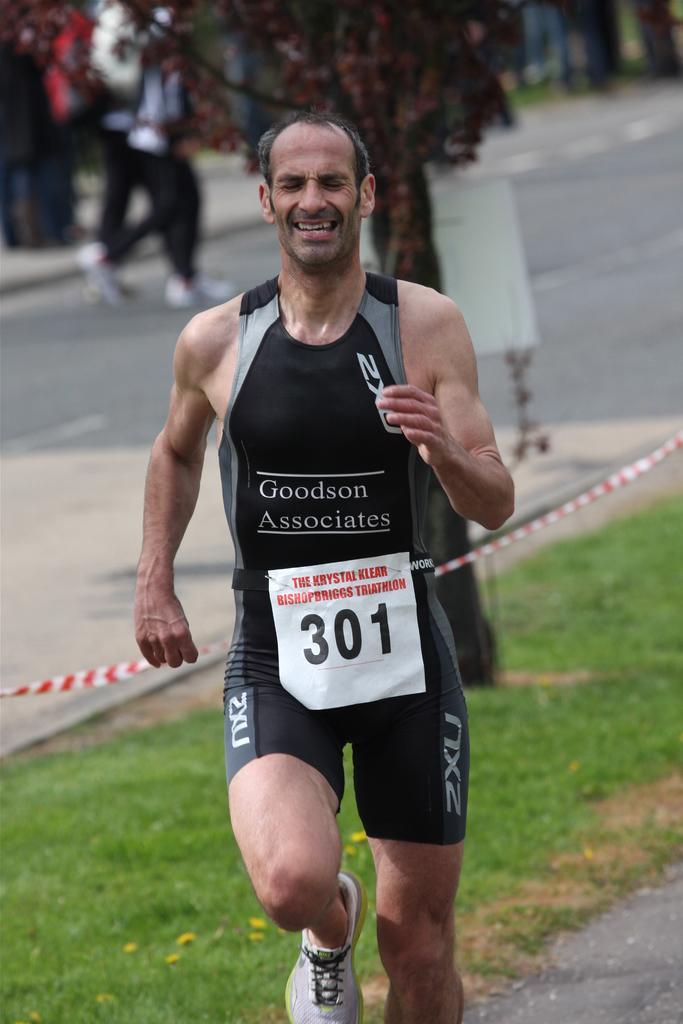<image>
Describe the image concisely. Triathlon competitor number 301 is wearing a shirt that says Goodson Associates. 